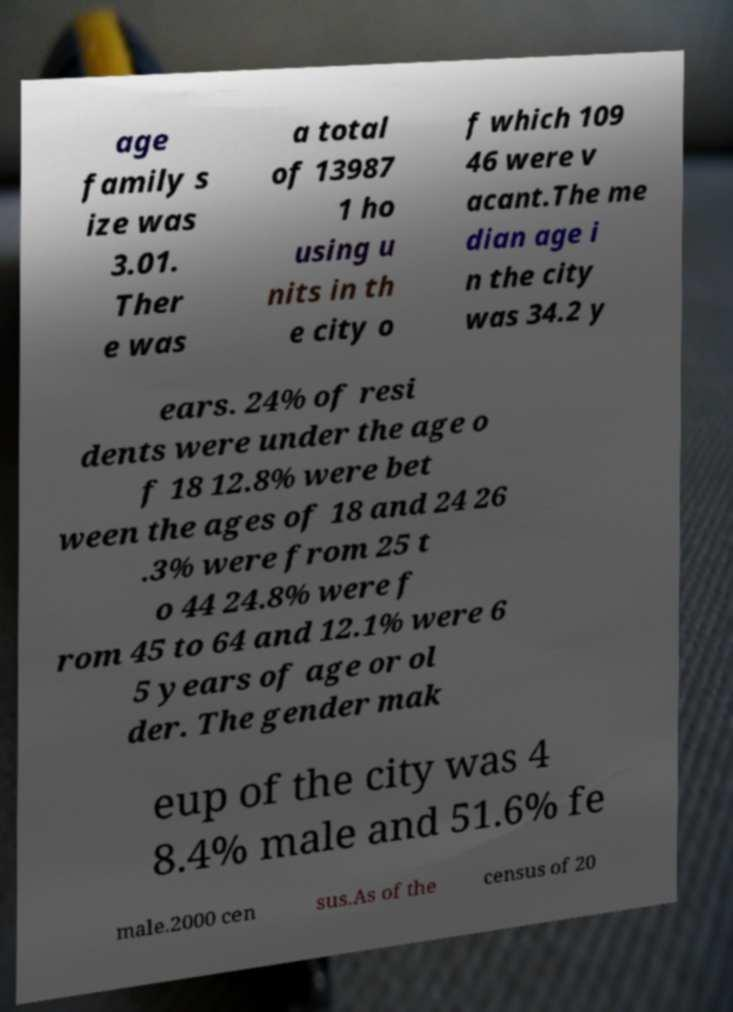For documentation purposes, I need the text within this image transcribed. Could you provide that? age family s ize was 3.01. Ther e was a total of 13987 1 ho using u nits in th e city o f which 109 46 were v acant.The me dian age i n the city was 34.2 y ears. 24% of resi dents were under the age o f 18 12.8% were bet ween the ages of 18 and 24 26 .3% were from 25 t o 44 24.8% were f rom 45 to 64 and 12.1% were 6 5 years of age or ol der. The gender mak eup of the city was 4 8.4% male and 51.6% fe male.2000 cen sus.As of the census of 20 